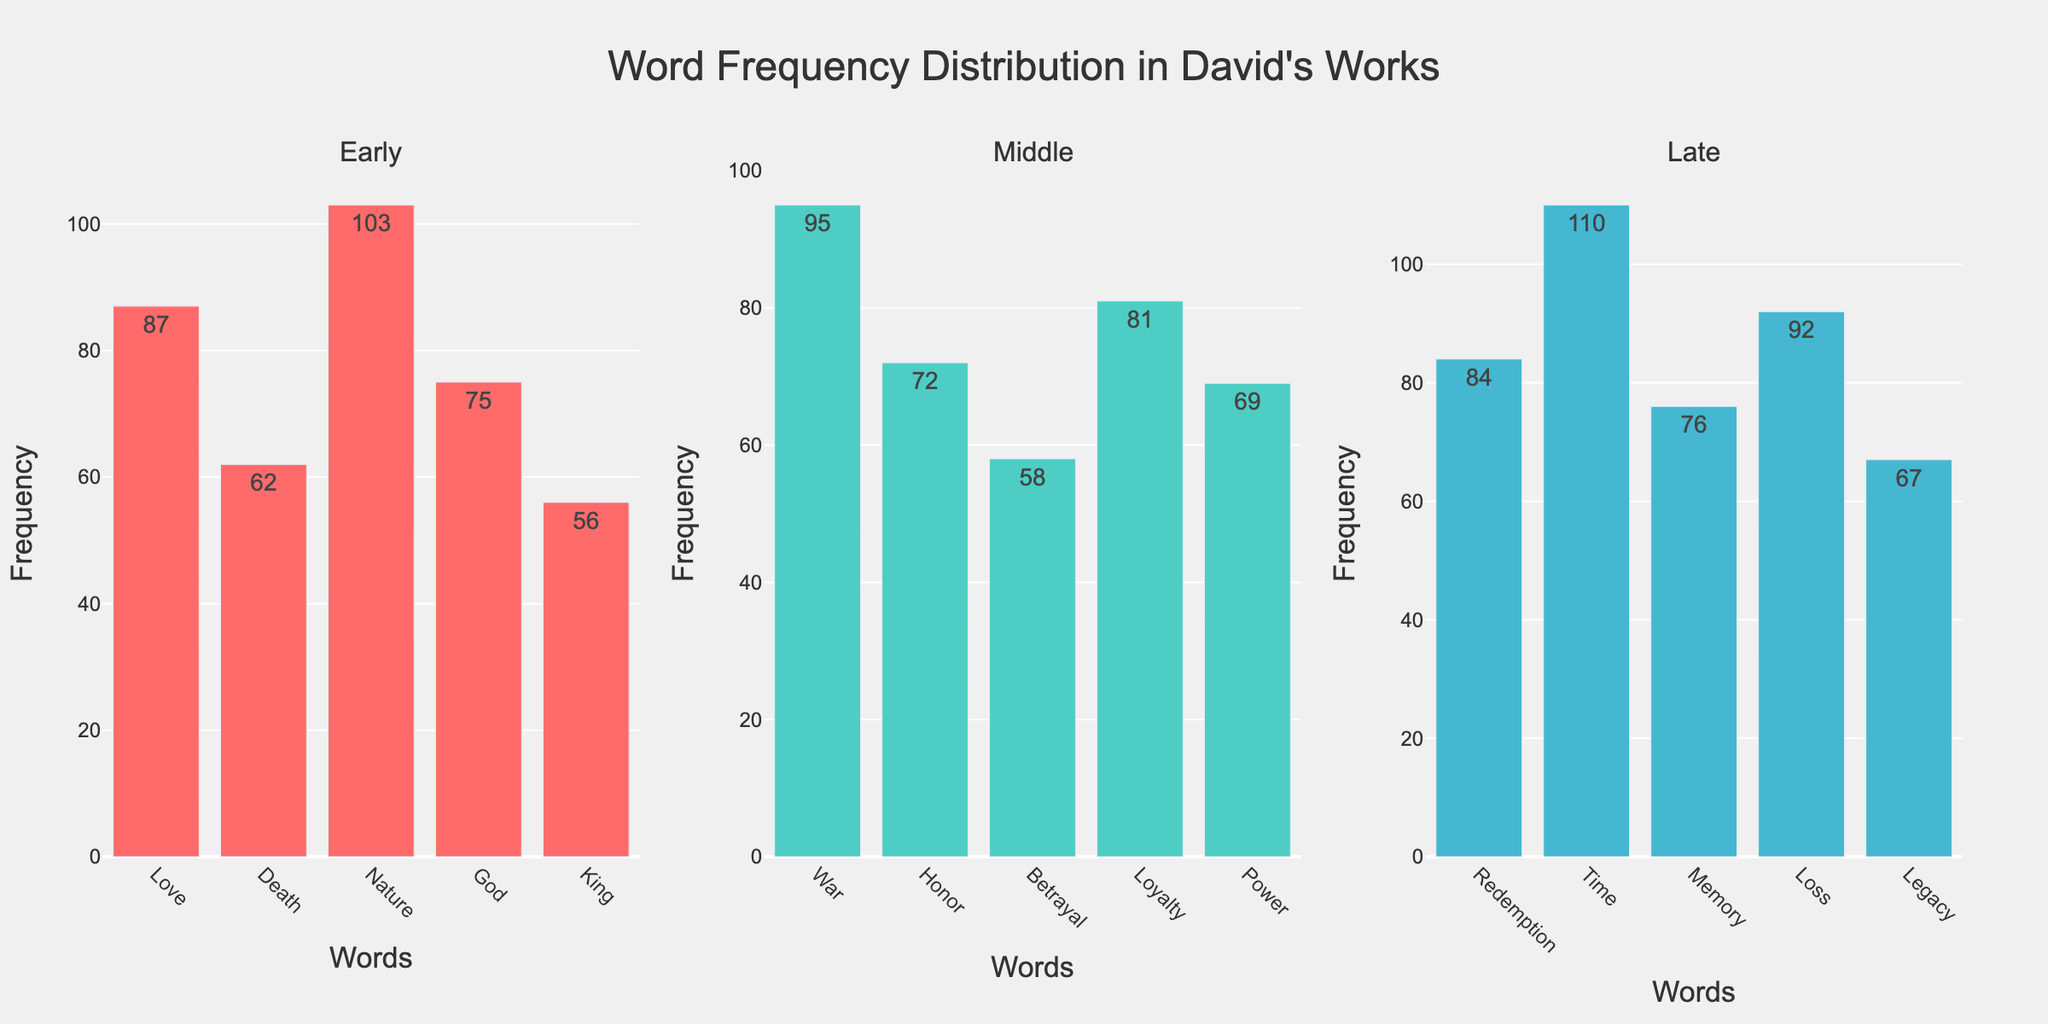How are the words categorized in the subplot? The words are categorized based on their literary periods: Early, Middle, and Late. Each subplot represents one of these periods.
Answer: Early, Middle, Late Which period has the highest frequency for any word, and what is that word? The 'Late' period has the highest frequency for the word 'Time' with a frequency of 110.
Answer: Late, Time What is the total frequency of words in the Early period? To find this, sum the frequencies of all the words in the Early period: 87 (Love) + 62 (Death) + 103 (Nature) + 75 (God) + 56 (King) = 383.
Answer: 383 Which word in the Middle period has the highest frequency, and what is its frequency? The word 'War' has the highest frequency in the Middle period with a frequency of 95.
Answer: War, 95 Compare the frequency of the word 'Love' in the Early period with the word 'Loss' in the Late period. Which one is higher and by how much? 'Love' in the Early period has a frequency of 87, and 'Loss' in the Late period has a frequency of 92. 'Loss' is higher by 92 - 87 = 5.
Answer: Loss, 5 Which word has the lowest frequency in the Early period, and what is its value? The word 'King' has the lowest frequency in the Early period with a frequency of 56.
Answer: King, 56 What is the average frequency of words in the Late period? To find this, sum the frequencies of all words in the Late period and divide by the number of words: (84 + 110 + 76 + 92 + 67) / 5 = 429 / 5 = 85.8.
Answer: 85.8 Between the words 'War' in the Middle period and 'Redemption' in the Late period, which one is more frequent? 'War' has a frequency of 95 in the Middle period while 'Redemption' has a frequency of 84 in the Late period. Therefore, 'War' is more frequent.
Answer: War How does the frequency of 'Nature' in the Early period compare to the combined frequency of 'Honor' and 'Power' in the Middle period? 'Nature' has a frequency of 103. The combined frequency of 'Honor' (72) and 'Power' (69) is 72 + 69 = 141. Therefore, 'Nature' is less frequent by 141 - 103 = 38.
Answer: less by 38 